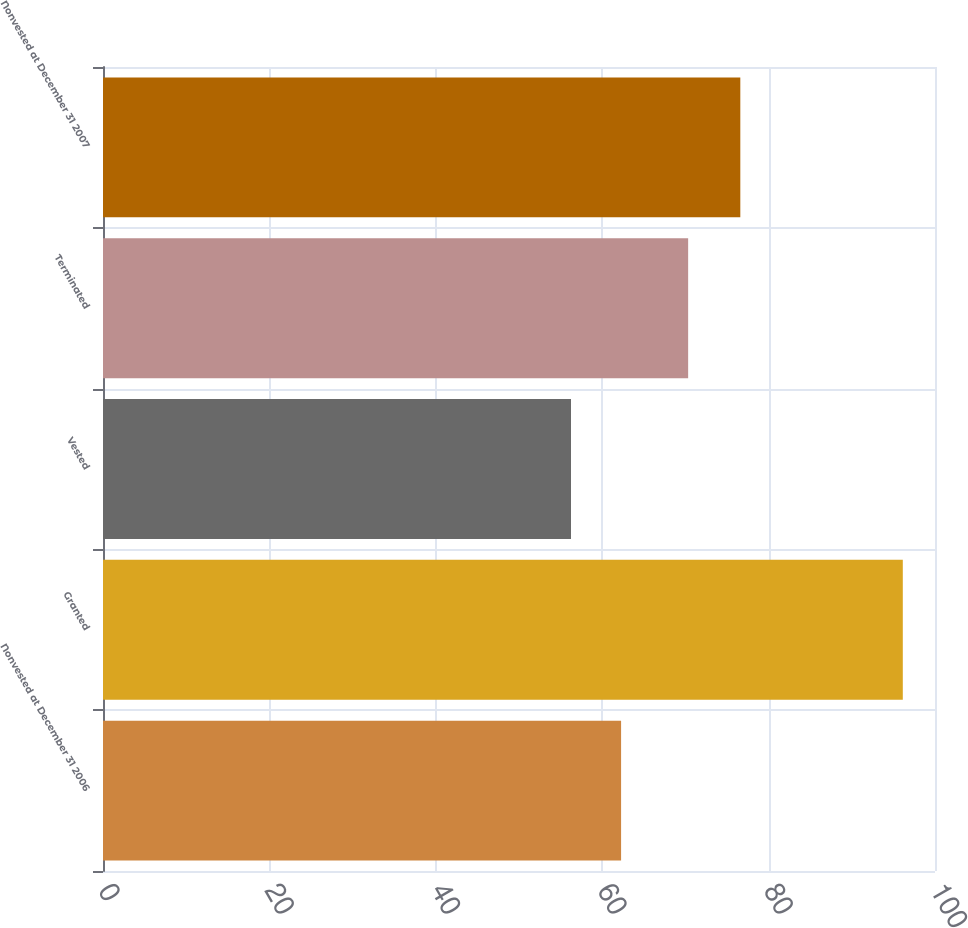<chart> <loc_0><loc_0><loc_500><loc_500><bar_chart><fcel>Nonvested at December 31 2006<fcel>Granted<fcel>Vested<fcel>Terminated<fcel>Nonvested at December 31 2007<nl><fcel>62.27<fcel>96.13<fcel>56.25<fcel>70.33<fcel>76.6<nl></chart> 